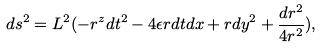Convert formula to latex. <formula><loc_0><loc_0><loc_500><loc_500>d s ^ { 2 } = L ^ { 2 } ( - r ^ { z } d t ^ { 2 } - 4 \epsilon r d t d x + r d y ^ { 2 } + \frac { d r ^ { 2 } } { 4 r ^ { 2 } } ) ,</formula> 